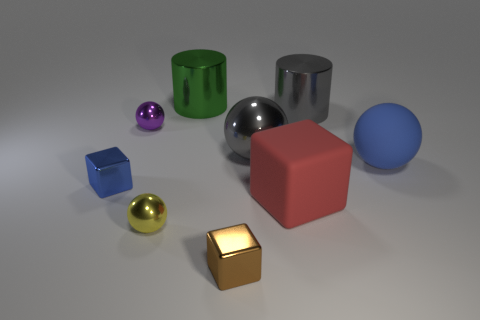There is a red rubber thing that is behind the metallic ball in front of the shiny block on the left side of the green thing; what shape is it?
Your response must be concise. Cube. What shape is the thing that is the same color as the matte ball?
Offer a very short reply. Cube. Is there a big gray shiny cylinder?
Give a very brief answer. Yes. There is a yellow thing; is its size the same as the blue thing to the left of the big rubber sphere?
Make the answer very short. Yes. Is there a shiny cylinder that is behind the ball in front of the small blue block?
Provide a short and direct response. Yes. What is the sphere that is both in front of the large gray metal sphere and behind the yellow ball made of?
Your answer should be very brief. Rubber. The tiny shiny block that is on the left side of the small ball in front of the large matte object behind the large block is what color?
Give a very brief answer. Blue. There is another cube that is the same size as the blue cube; what color is it?
Your answer should be very brief. Brown. There is a rubber ball; is its color the same as the shiny cube that is behind the small brown shiny object?
Make the answer very short. Yes. The large gray thing that is right of the matte object that is left of the big rubber ball is made of what material?
Give a very brief answer. Metal. 